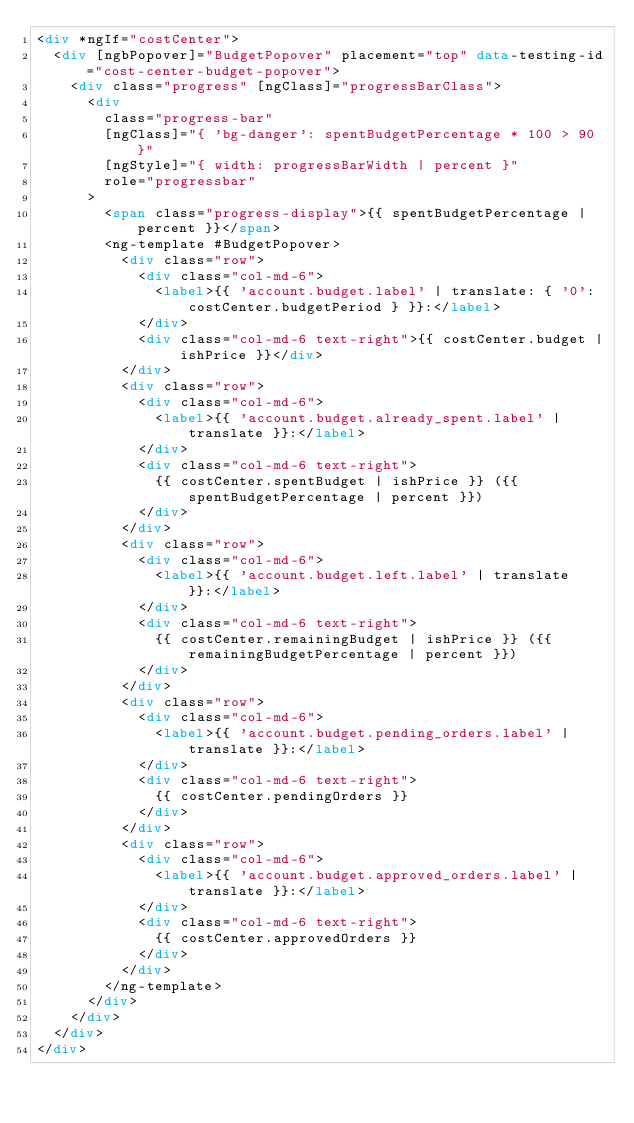<code> <loc_0><loc_0><loc_500><loc_500><_HTML_><div *ngIf="costCenter">
  <div [ngbPopover]="BudgetPopover" placement="top" data-testing-id="cost-center-budget-popover">
    <div class="progress" [ngClass]="progressBarClass">
      <div
        class="progress-bar"
        [ngClass]="{ 'bg-danger': spentBudgetPercentage * 100 > 90 }"
        [ngStyle]="{ width: progressBarWidth | percent }"
        role="progressbar"
      >
        <span class="progress-display">{{ spentBudgetPercentage | percent }}</span>
        <ng-template #BudgetPopover>
          <div class="row">
            <div class="col-md-6">
              <label>{{ 'account.budget.label' | translate: { '0': costCenter.budgetPeriod } }}:</label>
            </div>
            <div class="col-md-6 text-right">{{ costCenter.budget | ishPrice }}</div>
          </div>
          <div class="row">
            <div class="col-md-6">
              <label>{{ 'account.budget.already_spent.label' | translate }}:</label>
            </div>
            <div class="col-md-6 text-right">
              {{ costCenter.spentBudget | ishPrice }} ({{ spentBudgetPercentage | percent }})
            </div>
          </div>
          <div class="row">
            <div class="col-md-6">
              <label>{{ 'account.budget.left.label' | translate }}:</label>
            </div>
            <div class="col-md-6 text-right">
              {{ costCenter.remainingBudget | ishPrice }} ({{ remainingBudgetPercentage | percent }})
            </div>
          </div>
          <div class="row">
            <div class="col-md-6">
              <label>{{ 'account.budget.pending_orders.label' | translate }}:</label>
            </div>
            <div class="col-md-6 text-right">
              {{ costCenter.pendingOrders }}
            </div>
          </div>
          <div class="row">
            <div class="col-md-6">
              <label>{{ 'account.budget.approved_orders.label' | translate }}:</label>
            </div>
            <div class="col-md-6 text-right">
              {{ costCenter.approvedOrders }}
            </div>
          </div>
        </ng-template>
      </div>
    </div>
  </div>
</div>
</code> 